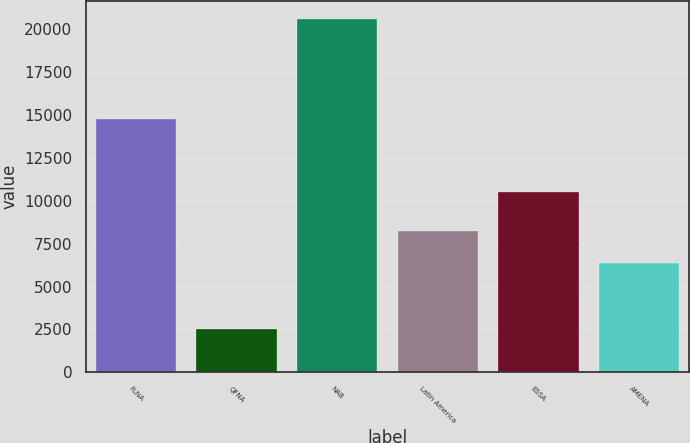Convert chart to OTSL. <chart><loc_0><loc_0><loc_500><loc_500><bar_chart><fcel>FLNA<fcel>QFNA<fcel>NAB<fcel>Latin America<fcel>ESSA<fcel>AMENA<nl><fcel>14782<fcel>2543<fcel>20618<fcel>8228<fcel>10510<fcel>6375<nl></chart> 